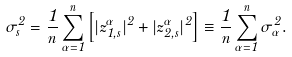<formula> <loc_0><loc_0><loc_500><loc_500>\sigma ^ { 2 } _ { s } = \frac { 1 } { n } \sum _ { \alpha = 1 } ^ { n } \left [ | z _ { 1 , s } ^ { \alpha } | ^ { 2 } + | z _ { 2 , s } ^ { \alpha } | ^ { 2 } \right ] \equiv \frac { 1 } { n } \sum _ { \alpha = 1 } ^ { n } \sigma ^ { 2 } _ { \alpha } .</formula> 